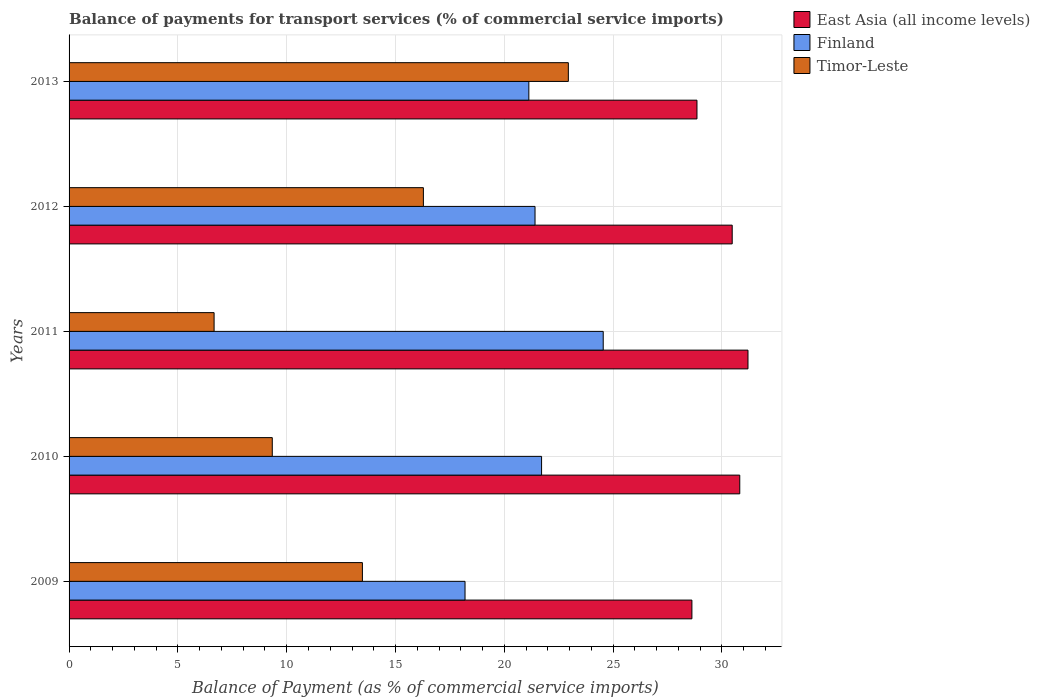Are the number of bars on each tick of the Y-axis equal?
Provide a short and direct response. Yes. How many bars are there on the 4th tick from the top?
Keep it short and to the point. 3. What is the label of the 2nd group of bars from the top?
Your answer should be very brief. 2012. What is the balance of payments for transport services in Finland in 2013?
Provide a short and direct response. 21.13. Across all years, what is the maximum balance of payments for transport services in East Asia (all income levels)?
Offer a terse response. 31.2. Across all years, what is the minimum balance of payments for transport services in Timor-Leste?
Your answer should be very brief. 6.66. What is the total balance of payments for transport services in Timor-Leste in the graph?
Give a very brief answer. 68.7. What is the difference between the balance of payments for transport services in Timor-Leste in 2009 and that in 2012?
Offer a terse response. -2.8. What is the difference between the balance of payments for transport services in Finland in 2009 and the balance of payments for transport services in Timor-Leste in 2011?
Your answer should be very brief. 11.53. What is the average balance of payments for transport services in Timor-Leste per year?
Your answer should be compact. 13.74. In the year 2009, what is the difference between the balance of payments for transport services in Finland and balance of payments for transport services in East Asia (all income levels)?
Offer a very short reply. -10.43. What is the ratio of the balance of payments for transport services in Timor-Leste in 2010 to that in 2013?
Your response must be concise. 0.41. Is the difference between the balance of payments for transport services in Finland in 2010 and 2011 greater than the difference between the balance of payments for transport services in East Asia (all income levels) in 2010 and 2011?
Your answer should be compact. No. What is the difference between the highest and the second highest balance of payments for transport services in Finland?
Ensure brevity in your answer.  2.83. What is the difference between the highest and the lowest balance of payments for transport services in Timor-Leste?
Your response must be concise. 16.28. In how many years, is the balance of payments for transport services in Timor-Leste greater than the average balance of payments for transport services in Timor-Leste taken over all years?
Provide a short and direct response. 2. What does the 3rd bar from the top in 2011 represents?
Ensure brevity in your answer.  East Asia (all income levels). What does the 2nd bar from the bottom in 2010 represents?
Provide a succinct answer. Finland. How many bars are there?
Offer a very short reply. 15. Are all the bars in the graph horizontal?
Keep it short and to the point. Yes. How many years are there in the graph?
Your answer should be very brief. 5. Are the values on the major ticks of X-axis written in scientific E-notation?
Provide a short and direct response. No. Does the graph contain any zero values?
Your answer should be very brief. No. Does the graph contain grids?
Your answer should be compact. Yes. Where does the legend appear in the graph?
Your answer should be compact. Top right. How many legend labels are there?
Ensure brevity in your answer.  3. What is the title of the graph?
Your answer should be very brief. Balance of payments for transport services (% of commercial service imports). Does "Tunisia" appear as one of the legend labels in the graph?
Give a very brief answer. No. What is the label or title of the X-axis?
Make the answer very short. Balance of Payment (as % of commercial service imports). What is the Balance of Payment (as % of commercial service imports) of East Asia (all income levels) in 2009?
Give a very brief answer. 28.62. What is the Balance of Payment (as % of commercial service imports) of Finland in 2009?
Ensure brevity in your answer.  18.19. What is the Balance of Payment (as % of commercial service imports) of Timor-Leste in 2009?
Provide a short and direct response. 13.48. What is the Balance of Payment (as % of commercial service imports) in East Asia (all income levels) in 2010?
Offer a very short reply. 30.82. What is the Balance of Payment (as % of commercial service imports) in Finland in 2010?
Give a very brief answer. 21.71. What is the Balance of Payment (as % of commercial service imports) in Timor-Leste in 2010?
Your answer should be compact. 9.34. What is the Balance of Payment (as % of commercial service imports) of East Asia (all income levels) in 2011?
Make the answer very short. 31.2. What is the Balance of Payment (as % of commercial service imports) of Finland in 2011?
Give a very brief answer. 24.54. What is the Balance of Payment (as % of commercial service imports) of Timor-Leste in 2011?
Ensure brevity in your answer.  6.66. What is the Balance of Payment (as % of commercial service imports) of East Asia (all income levels) in 2012?
Offer a terse response. 30.47. What is the Balance of Payment (as % of commercial service imports) in Finland in 2012?
Your answer should be compact. 21.41. What is the Balance of Payment (as % of commercial service imports) of Timor-Leste in 2012?
Offer a very short reply. 16.28. What is the Balance of Payment (as % of commercial service imports) of East Asia (all income levels) in 2013?
Keep it short and to the point. 28.85. What is the Balance of Payment (as % of commercial service imports) in Finland in 2013?
Keep it short and to the point. 21.13. What is the Balance of Payment (as % of commercial service imports) of Timor-Leste in 2013?
Offer a terse response. 22.94. Across all years, what is the maximum Balance of Payment (as % of commercial service imports) of East Asia (all income levels)?
Provide a succinct answer. 31.2. Across all years, what is the maximum Balance of Payment (as % of commercial service imports) of Finland?
Keep it short and to the point. 24.54. Across all years, what is the maximum Balance of Payment (as % of commercial service imports) of Timor-Leste?
Offer a very short reply. 22.94. Across all years, what is the minimum Balance of Payment (as % of commercial service imports) of East Asia (all income levels)?
Your answer should be compact. 28.62. Across all years, what is the minimum Balance of Payment (as % of commercial service imports) in Finland?
Your answer should be very brief. 18.19. Across all years, what is the minimum Balance of Payment (as % of commercial service imports) of Timor-Leste?
Provide a short and direct response. 6.66. What is the total Balance of Payment (as % of commercial service imports) in East Asia (all income levels) in the graph?
Your answer should be compact. 149.95. What is the total Balance of Payment (as % of commercial service imports) of Finland in the graph?
Provide a succinct answer. 106.98. What is the total Balance of Payment (as % of commercial service imports) in Timor-Leste in the graph?
Your answer should be compact. 68.7. What is the difference between the Balance of Payment (as % of commercial service imports) in East Asia (all income levels) in 2009 and that in 2010?
Give a very brief answer. -2.2. What is the difference between the Balance of Payment (as % of commercial service imports) in Finland in 2009 and that in 2010?
Your answer should be compact. -3.52. What is the difference between the Balance of Payment (as % of commercial service imports) of Timor-Leste in 2009 and that in 2010?
Give a very brief answer. 4.14. What is the difference between the Balance of Payment (as % of commercial service imports) of East Asia (all income levels) in 2009 and that in 2011?
Offer a very short reply. -2.58. What is the difference between the Balance of Payment (as % of commercial service imports) of Finland in 2009 and that in 2011?
Offer a very short reply. -6.35. What is the difference between the Balance of Payment (as % of commercial service imports) in Timor-Leste in 2009 and that in 2011?
Offer a terse response. 6.81. What is the difference between the Balance of Payment (as % of commercial service imports) in East Asia (all income levels) in 2009 and that in 2012?
Your answer should be very brief. -1.85. What is the difference between the Balance of Payment (as % of commercial service imports) of Finland in 2009 and that in 2012?
Offer a very short reply. -3.22. What is the difference between the Balance of Payment (as % of commercial service imports) of Timor-Leste in 2009 and that in 2012?
Your answer should be compact. -2.8. What is the difference between the Balance of Payment (as % of commercial service imports) of East Asia (all income levels) in 2009 and that in 2013?
Your answer should be very brief. -0.23. What is the difference between the Balance of Payment (as % of commercial service imports) in Finland in 2009 and that in 2013?
Make the answer very short. -2.93. What is the difference between the Balance of Payment (as % of commercial service imports) of Timor-Leste in 2009 and that in 2013?
Your answer should be very brief. -9.46. What is the difference between the Balance of Payment (as % of commercial service imports) of East Asia (all income levels) in 2010 and that in 2011?
Give a very brief answer. -0.38. What is the difference between the Balance of Payment (as % of commercial service imports) of Finland in 2010 and that in 2011?
Provide a short and direct response. -2.83. What is the difference between the Balance of Payment (as % of commercial service imports) in Timor-Leste in 2010 and that in 2011?
Make the answer very short. 2.67. What is the difference between the Balance of Payment (as % of commercial service imports) of East Asia (all income levels) in 2010 and that in 2012?
Your response must be concise. 0.35. What is the difference between the Balance of Payment (as % of commercial service imports) in Finland in 2010 and that in 2012?
Provide a short and direct response. 0.3. What is the difference between the Balance of Payment (as % of commercial service imports) in Timor-Leste in 2010 and that in 2012?
Your answer should be compact. -6.94. What is the difference between the Balance of Payment (as % of commercial service imports) in East Asia (all income levels) in 2010 and that in 2013?
Make the answer very short. 1.97. What is the difference between the Balance of Payment (as % of commercial service imports) of Finland in 2010 and that in 2013?
Keep it short and to the point. 0.58. What is the difference between the Balance of Payment (as % of commercial service imports) of Timor-Leste in 2010 and that in 2013?
Your answer should be compact. -13.6. What is the difference between the Balance of Payment (as % of commercial service imports) in East Asia (all income levels) in 2011 and that in 2012?
Make the answer very short. 0.72. What is the difference between the Balance of Payment (as % of commercial service imports) in Finland in 2011 and that in 2012?
Provide a succinct answer. 3.13. What is the difference between the Balance of Payment (as % of commercial service imports) of Timor-Leste in 2011 and that in 2012?
Provide a succinct answer. -9.62. What is the difference between the Balance of Payment (as % of commercial service imports) in East Asia (all income levels) in 2011 and that in 2013?
Ensure brevity in your answer.  2.34. What is the difference between the Balance of Payment (as % of commercial service imports) of Finland in 2011 and that in 2013?
Provide a succinct answer. 3.42. What is the difference between the Balance of Payment (as % of commercial service imports) of Timor-Leste in 2011 and that in 2013?
Your answer should be compact. -16.28. What is the difference between the Balance of Payment (as % of commercial service imports) in East Asia (all income levels) in 2012 and that in 2013?
Provide a succinct answer. 1.62. What is the difference between the Balance of Payment (as % of commercial service imports) in Finland in 2012 and that in 2013?
Your answer should be very brief. 0.28. What is the difference between the Balance of Payment (as % of commercial service imports) in Timor-Leste in 2012 and that in 2013?
Provide a succinct answer. -6.66. What is the difference between the Balance of Payment (as % of commercial service imports) of East Asia (all income levels) in 2009 and the Balance of Payment (as % of commercial service imports) of Finland in 2010?
Ensure brevity in your answer.  6.91. What is the difference between the Balance of Payment (as % of commercial service imports) in East Asia (all income levels) in 2009 and the Balance of Payment (as % of commercial service imports) in Timor-Leste in 2010?
Ensure brevity in your answer.  19.28. What is the difference between the Balance of Payment (as % of commercial service imports) of Finland in 2009 and the Balance of Payment (as % of commercial service imports) of Timor-Leste in 2010?
Your answer should be very brief. 8.86. What is the difference between the Balance of Payment (as % of commercial service imports) in East Asia (all income levels) in 2009 and the Balance of Payment (as % of commercial service imports) in Finland in 2011?
Offer a very short reply. 4.08. What is the difference between the Balance of Payment (as % of commercial service imports) in East Asia (all income levels) in 2009 and the Balance of Payment (as % of commercial service imports) in Timor-Leste in 2011?
Make the answer very short. 21.96. What is the difference between the Balance of Payment (as % of commercial service imports) in Finland in 2009 and the Balance of Payment (as % of commercial service imports) in Timor-Leste in 2011?
Your answer should be very brief. 11.53. What is the difference between the Balance of Payment (as % of commercial service imports) in East Asia (all income levels) in 2009 and the Balance of Payment (as % of commercial service imports) in Finland in 2012?
Your response must be concise. 7.21. What is the difference between the Balance of Payment (as % of commercial service imports) in East Asia (all income levels) in 2009 and the Balance of Payment (as % of commercial service imports) in Timor-Leste in 2012?
Your answer should be very brief. 12.34. What is the difference between the Balance of Payment (as % of commercial service imports) of Finland in 2009 and the Balance of Payment (as % of commercial service imports) of Timor-Leste in 2012?
Give a very brief answer. 1.91. What is the difference between the Balance of Payment (as % of commercial service imports) in East Asia (all income levels) in 2009 and the Balance of Payment (as % of commercial service imports) in Finland in 2013?
Your response must be concise. 7.49. What is the difference between the Balance of Payment (as % of commercial service imports) in East Asia (all income levels) in 2009 and the Balance of Payment (as % of commercial service imports) in Timor-Leste in 2013?
Ensure brevity in your answer.  5.68. What is the difference between the Balance of Payment (as % of commercial service imports) in Finland in 2009 and the Balance of Payment (as % of commercial service imports) in Timor-Leste in 2013?
Your response must be concise. -4.75. What is the difference between the Balance of Payment (as % of commercial service imports) in East Asia (all income levels) in 2010 and the Balance of Payment (as % of commercial service imports) in Finland in 2011?
Offer a terse response. 6.27. What is the difference between the Balance of Payment (as % of commercial service imports) in East Asia (all income levels) in 2010 and the Balance of Payment (as % of commercial service imports) in Timor-Leste in 2011?
Provide a short and direct response. 24.15. What is the difference between the Balance of Payment (as % of commercial service imports) of Finland in 2010 and the Balance of Payment (as % of commercial service imports) of Timor-Leste in 2011?
Offer a very short reply. 15.05. What is the difference between the Balance of Payment (as % of commercial service imports) in East Asia (all income levels) in 2010 and the Balance of Payment (as % of commercial service imports) in Finland in 2012?
Your response must be concise. 9.41. What is the difference between the Balance of Payment (as % of commercial service imports) of East Asia (all income levels) in 2010 and the Balance of Payment (as % of commercial service imports) of Timor-Leste in 2012?
Provide a succinct answer. 14.54. What is the difference between the Balance of Payment (as % of commercial service imports) of Finland in 2010 and the Balance of Payment (as % of commercial service imports) of Timor-Leste in 2012?
Ensure brevity in your answer.  5.43. What is the difference between the Balance of Payment (as % of commercial service imports) in East Asia (all income levels) in 2010 and the Balance of Payment (as % of commercial service imports) in Finland in 2013?
Ensure brevity in your answer.  9.69. What is the difference between the Balance of Payment (as % of commercial service imports) of East Asia (all income levels) in 2010 and the Balance of Payment (as % of commercial service imports) of Timor-Leste in 2013?
Ensure brevity in your answer.  7.88. What is the difference between the Balance of Payment (as % of commercial service imports) in Finland in 2010 and the Balance of Payment (as % of commercial service imports) in Timor-Leste in 2013?
Ensure brevity in your answer.  -1.23. What is the difference between the Balance of Payment (as % of commercial service imports) of East Asia (all income levels) in 2011 and the Balance of Payment (as % of commercial service imports) of Finland in 2012?
Make the answer very short. 9.79. What is the difference between the Balance of Payment (as % of commercial service imports) in East Asia (all income levels) in 2011 and the Balance of Payment (as % of commercial service imports) in Timor-Leste in 2012?
Ensure brevity in your answer.  14.91. What is the difference between the Balance of Payment (as % of commercial service imports) in Finland in 2011 and the Balance of Payment (as % of commercial service imports) in Timor-Leste in 2012?
Offer a very short reply. 8.26. What is the difference between the Balance of Payment (as % of commercial service imports) in East Asia (all income levels) in 2011 and the Balance of Payment (as % of commercial service imports) in Finland in 2013?
Offer a terse response. 10.07. What is the difference between the Balance of Payment (as % of commercial service imports) of East Asia (all income levels) in 2011 and the Balance of Payment (as % of commercial service imports) of Timor-Leste in 2013?
Make the answer very short. 8.25. What is the difference between the Balance of Payment (as % of commercial service imports) in Finland in 2011 and the Balance of Payment (as % of commercial service imports) in Timor-Leste in 2013?
Your answer should be very brief. 1.6. What is the difference between the Balance of Payment (as % of commercial service imports) of East Asia (all income levels) in 2012 and the Balance of Payment (as % of commercial service imports) of Finland in 2013?
Your answer should be compact. 9.34. What is the difference between the Balance of Payment (as % of commercial service imports) in East Asia (all income levels) in 2012 and the Balance of Payment (as % of commercial service imports) in Timor-Leste in 2013?
Provide a succinct answer. 7.53. What is the difference between the Balance of Payment (as % of commercial service imports) of Finland in 2012 and the Balance of Payment (as % of commercial service imports) of Timor-Leste in 2013?
Offer a terse response. -1.53. What is the average Balance of Payment (as % of commercial service imports) in East Asia (all income levels) per year?
Keep it short and to the point. 29.99. What is the average Balance of Payment (as % of commercial service imports) of Finland per year?
Your answer should be very brief. 21.4. What is the average Balance of Payment (as % of commercial service imports) in Timor-Leste per year?
Provide a short and direct response. 13.74. In the year 2009, what is the difference between the Balance of Payment (as % of commercial service imports) of East Asia (all income levels) and Balance of Payment (as % of commercial service imports) of Finland?
Offer a terse response. 10.43. In the year 2009, what is the difference between the Balance of Payment (as % of commercial service imports) in East Asia (all income levels) and Balance of Payment (as % of commercial service imports) in Timor-Leste?
Give a very brief answer. 15.14. In the year 2009, what is the difference between the Balance of Payment (as % of commercial service imports) of Finland and Balance of Payment (as % of commercial service imports) of Timor-Leste?
Your answer should be compact. 4.72. In the year 2010, what is the difference between the Balance of Payment (as % of commercial service imports) of East Asia (all income levels) and Balance of Payment (as % of commercial service imports) of Finland?
Your answer should be compact. 9.11. In the year 2010, what is the difference between the Balance of Payment (as % of commercial service imports) of East Asia (all income levels) and Balance of Payment (as % of commercial service imports) of Timor-Leste?
Offer a very short reply. 21.48. In the year 2010, what is the difference between the Balance of Payment (as % of commercial service imports) of Finland and Balance of Payment (as % of commercial service imports) of Timor-Leste?
Provide a short and direct response. 12.37. In the year 2011, what is the difference between the Balance of Payment (as % of commercial service imports) in East Asia (all income levels) and Balance of Payment (as % of commercial service imports) in Finland?
Provide a short and direct response. 6.65. In the year 2011, what is the difference between the Balance of Payment (as % of commercial service imports) in East Asia (all income levels) and Balance of Payment (as % of commercial service imports) in Timor-Leste?
Keep it short and to the point. 24.53. In the year 2011, what is the difference between the Balance of Payment (as % of commercial service imports) in Finland and Balance of Payment (as % of commercial service imports) in Timor-Leste?
Keep it short and to the point. 17.88. In the year 2012, what is the difference between the Balance of Payment (as % of commercial service imports) in East Asia (all income levels) and Balance of Payment (as % of commercial service imports) in Finland?
Offer a terse response. 9.06. In the year 2012, what is the difference between the Balance of Payment (as % of commercial service imports) of East Asia (all income levels) and Balance of Payment (as % of commercial service imports) of Timor-Leste?
Your answer should be compact. 14.19. In the year 2012, what is the difference between the Balance of Payment (as % of commercial service imports) of Finland and Balance of Payment (as % of commercial service imports) of Timor-Leste?
Give a very brief answer. 5.13. In the year 2013, what is the difference between the Balance of Payment (as % of commercial service imports) in East Asia (all income levels) and Balance of Payment (as % of commercial service imports) in Finland?
Keep it short and to the point. 7.73. In the year 2013, what is the difference between the Balance of Payment (as % of commercial service imports) of East Asia (all income levels) and Balance of Payment (as % of commercial service imports) of Timor-Leste?
Provide a succinct answer. 5.91. In the year 2013, what is the difference between the Balance of Payment (as % of commercial service imports) in Finland and Balance of Payment (as % of commercial service imports) in Timor-Leste?
Ensure brevity in your answer.  -1.82. What is the ratio of the Balance of Payment (as % of commercial service imports) of East Asia (all income levels) in 2009 to that in 2010?
Your answer should be compact. 0.93. What is the ratio of the Balance of Payment (as % of commercial service imports) of Finland in 2009 to that in 2010?
Provide a succinct answer. 0.84. What is the ratio of the Balance of Payment (as % of commercial service imports) in Timor-Leste in 2009 to that in 2010?
Your answer should be compact. 1.44. What is the ratio of the Balance of Payment (as % of commercial service imports) in East Asia (all income levels) in 2009 to that in 2011?
Provide a short and direct response. 0.92. What is the ratio of the Balance of Payment (as % of commercial service imports) in Finland in 2009 to that in 2011?
Provide a succinct answer. 0.74. What is the ratio of the Balance of Payment (as % of commercial service imports) in Timor-Leste in 2009 to that in 2011?
Your answer should be very brief. 2.02. What is the ratio of the Balance of Payment (as % of commercial service imports) in East Asia (all income levels) in 2009 to that in 2012?
Keep it short and to the point. 0.94. What is the ratio of the Balance of Payment (as % of commercial service imports) of Finland in 2009 to that in 2012?
Make the answer very short. 0.85. What is the ratio of the Balance of Payment (as % of commercial service imports) of Timor-Leste in 2009 to that in 2012?
Ensure brevity in your answer.  0.83. What is the ratio of the Balance of Payment (as % of commercial service imports) in Finland in 2009 to that in 2013?
Your answer should be compact. 0.86. What is the ratio of the Balance of Payment (as % of commercial service imports) of Timor-Leste in 2009 to that in 2013?
Make the answer very short. 0.59. What is the ratio of the Balance of Payment (as % of commercial service imports) of East Asia (all income levels) in 2010 to that in 2011?
Give a very brief answer. 0.99. What is the ratio of the Balance of Payment (as % of commercial service imports) of Finland in 2010 to that in 2011?
Offer a terse response. 0.88. What is the ratio of the Balance of Payment (as % of commercial service imports) in Timor-Leste in 2010 to that in 2011?
Your response must be concise. 1.4. What is the ratio of the Balance of Payment (as % of commercial service imports) in East Asia (all income levels) in 2010 to that in 2012?
Provide a succinct answer. 1.01. What is the ratio of the Balance of Payment (as % of commercial service imports) in Timor-Leste in 2010 to that in 2012?
Make the answer very short. 0.57. What is the ratio of the Balance of Payment (as % of commercial service imports) of East Asia (all income levels) in 2010 to that in 2013?
Provide a succinct answer. 1.07. What is the ratio of the Balance of Payment (as % of commercial service imports) in Finland in 2010 to that in 2013?
Provide a short and direct response. 1.03. What is the ratio of the Balance of Payment (as % of commercial service imports) in Timor-Leste in 2010 to that in 2013?
Ensure brevity in your answer.  0.41. What is the ratio of the Balance of Payment (as % of commercial service imports) in East Asia (all income levels) in 2011 to that in 2012?
Make the answer very short. 1.02. What is the ratio of the Balance of Payment (as % of commercial service imports) of Finland in 2011 to that in 2012?
Offer a very short reply. 1.15. What is the ratio of the Balance of Payment (as % of commercial service imports) in Timor-Leste in 2011 to that in 2012?
Offer a very short reply. 0.41. What is the ratio of the Balance of Payment (as % of commercial service imports) in East Asia (all income levels) in 2011 to that in 2013?
Offer a very short reply. 1.08. What is the ratio of the Balance of Payment (as % of commercial service imports) in Finland in 2011 to that in 2013?
Offer a terse response. 1.16. What is the ratio of the Balance of Payment (as % of commercial service imports) in Timor-Leste in 2011 to that in 2013?
Make the answer very short. 0.29. What is the ratio of the Balance of Payment (as % of commercial service imports) in East Asia (all income levels) in 2012 to that in 2013?
Ensure brevity in your answer.  1.06. What is the ratio of the Balance of Payment (as % of commercial service imports) in Finland in 2012 to that in 2013?
Keep it short and to the point. 1.01. What is the ratio of the Balance of Payment (as % of commercial service imports) of Timor-Leste in 2012 to that in 2013?
Your answer should be compact. 0.71. What is the difference between the highest and the second highest Balance of Payment (as % of commercial service imports) of East Asia (all income levels)?
Offer a terse response. 0.38. What is the difference between the highest and the second highest Balance of Payment (as % of commercial service imports) of Finland?
Provide a succinct answer. 2.83. What is the difference between the highest and the second highest Balance of Payment (as % of commercial service imports) in Timor-Leste?
Ensure brevity in your answer.  6.66. What is the difference between the highest and the lowest Balance of Payment (as % of commercial service imports) of East Asia (all income levels)?
Your answer should be compact. 2.58. What is the difference between the highest and the lowest Balance of Payment (as % of commercial service imports) in Finland?
Offer a terse response. 6.35. What is the difference between the highest and the lowest Balance of Payment (as % of commercial service imports) of Timor-Leste?
Your answer should be compact. 16.28. 